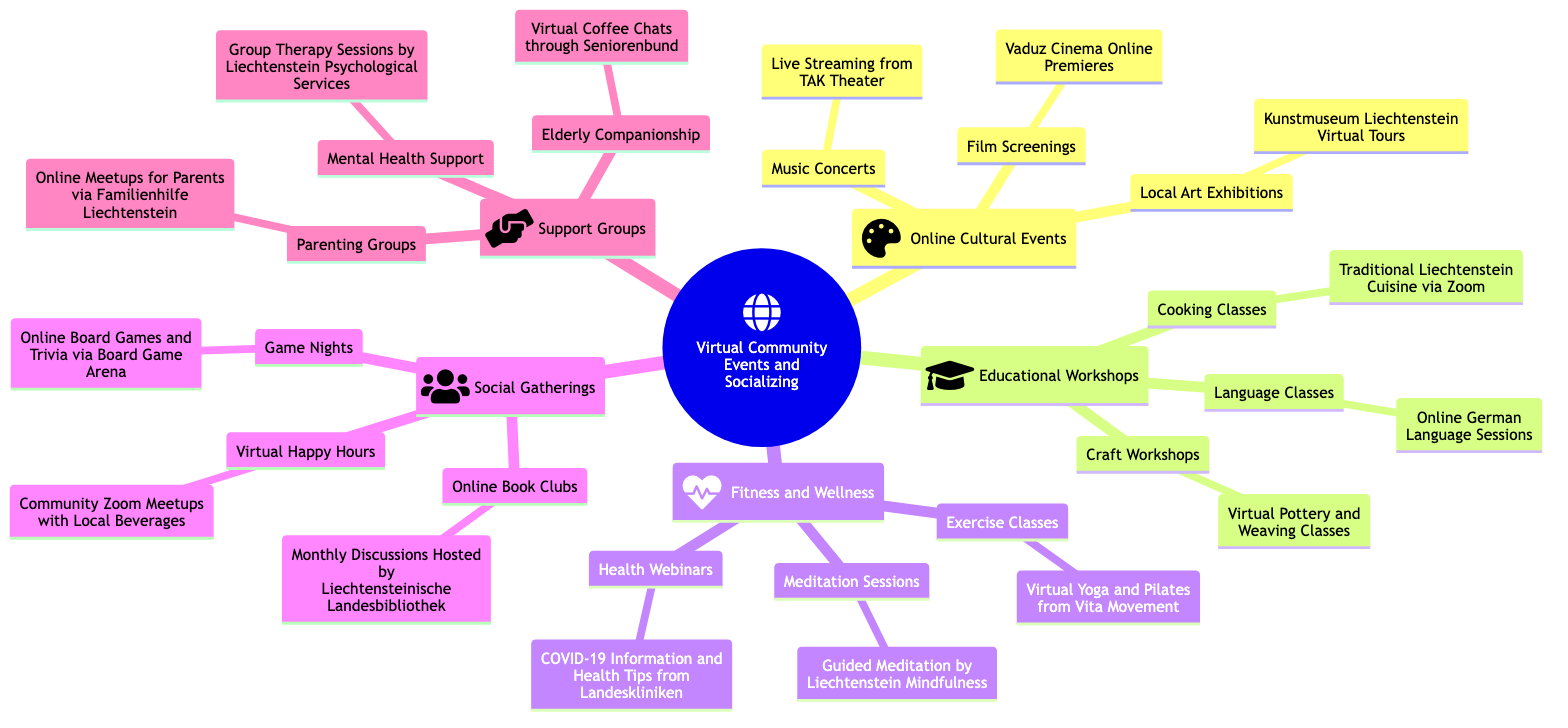What types of online events are included under "Online Cultural Events"? The diagram lists three specific types of online cultural events: local art exhibitions, music concerts, and film screenings. These are directly shown under the "Online Cultural Events" node.
Answer: local art exhibitions, music concerts, film screenings How many categories are there in total under "Virtual Community Events and Socializing Opportunities"? By counting the main nodes under "Virtual Community Events and Socializing Opportunities," there are five categories: Online Cultural Events, Educational Workshops, Fitness and Wellness, Social Gatherings, and Support Groups.
Answer: 5 Which organization hosts the online cooking classes? The node under Educational Workshops specifically states that the online cooking classes focus on Traditional Liechtenstein Cuisine and are conducted via Zoom, without mentioning any other organization.
Answer: Traditional Liechtenstein Cuisine via Zoom What type of support is offered under "Support Groups"? The diagram presents three types of support: mental health support, parenting groups, and elderly companionship. These support group options are found directly beneath the Support Groups category.
Answer: mental health support, parenting groups, elderly companionship How does the number of Online Cultural Events compare to Educational Workshops? There are three Online Cultural Events (local art exhibitions, music concerts, film screenings) and three Educational Workshops (language classes, cooking classes, craft workshops), making the numbers equal.
Answer: equal What specific event is associated with the “Virtual Happy Hours”? Looking at the Social Gatherings category, "Virtual Happy Hours" is described as Community Zoom Meetups with Local Beverages, indicating the type of event taking place.
Answer: Community Zoom Meetups with Local Beverages Which fitness activity is specifically mentioned in the “Fitness and Wellness” category? The diagram mentions Virtual Yoga and Pilates from Vita Movement as one specific exercise class offered within the Fitness and Wellness category.
Answer: Virtual Yoga and Pilates from Vita Movement How can a parent connect with others in "Support Groups"? The diagram states that there are online meetups for parents organized via Familienhilfe Liechtenstein, providing a specific path for parents to connect.
Answer: Online Meetups for Parents via Familienhilfe Liechtenstein 